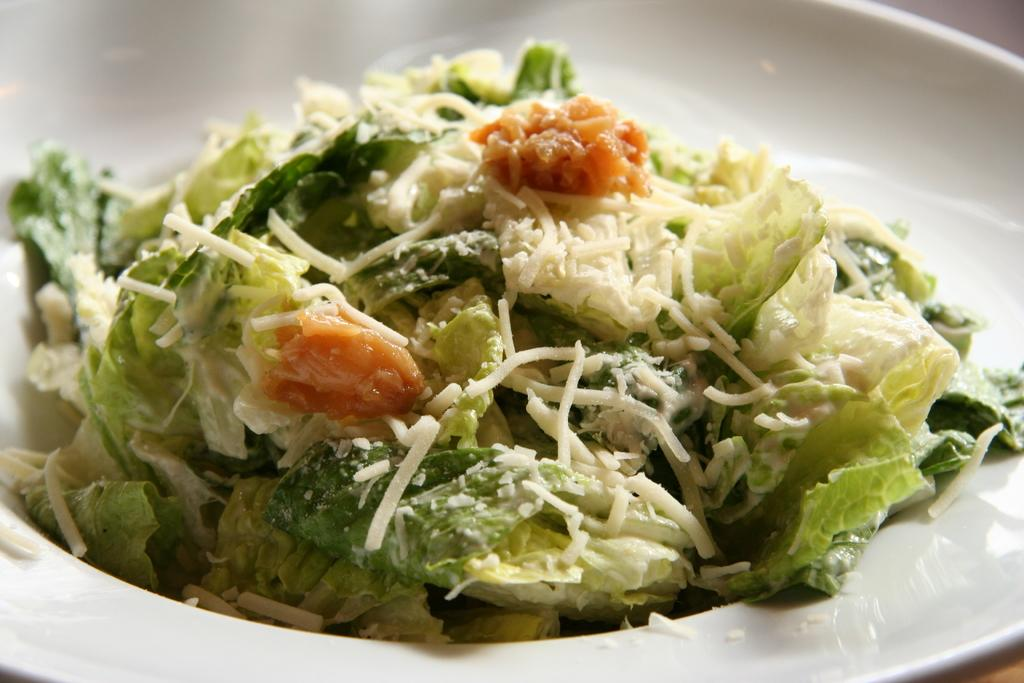What is on the white plate in the image? There is a food item on a white plate in the image. Can you describe the colors of the food item? The food has green, white, and brown colors. How many hens are sitting on the plants in the image? There are no hens or plants present in the image; it only features a food item on a white plate. 